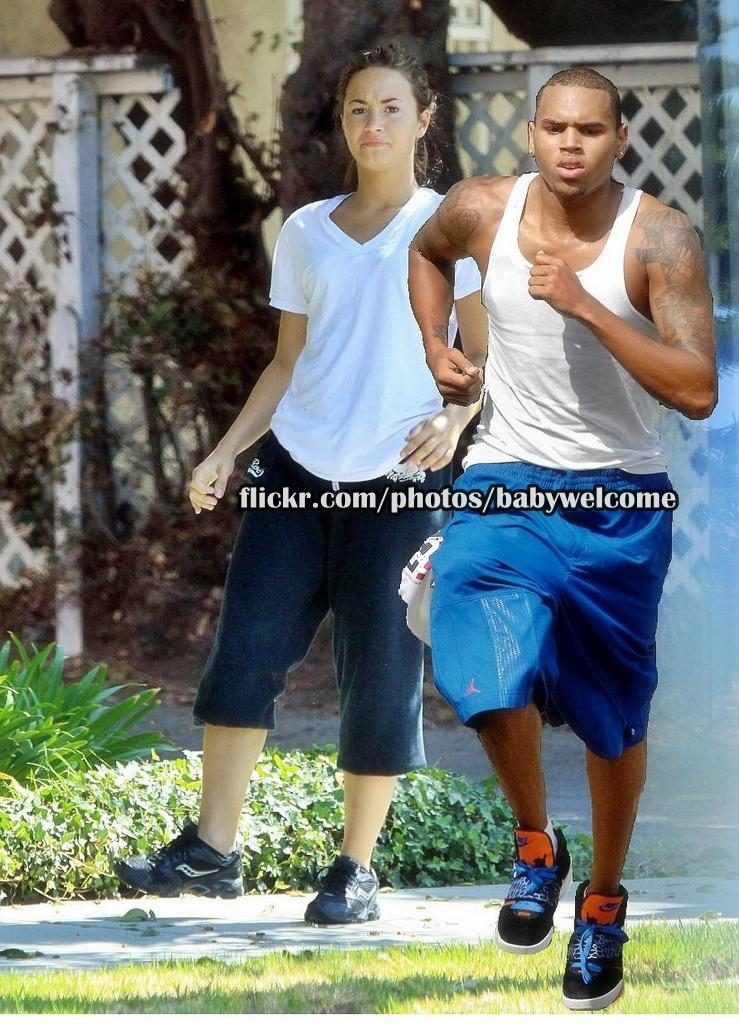What is the man doing on the right side of the image? The man is running on the right side of the image. Who is following the man? There is a woman walking behind the man. Where are the man and the woman located? Both the man and the woman are on the ground. What can be seen in the background of the image? There are trees, a fence, a wall, and plants in the background of the image. How does the dad increase the speed of the cake in the image? There is no dad or cake present in the image. 